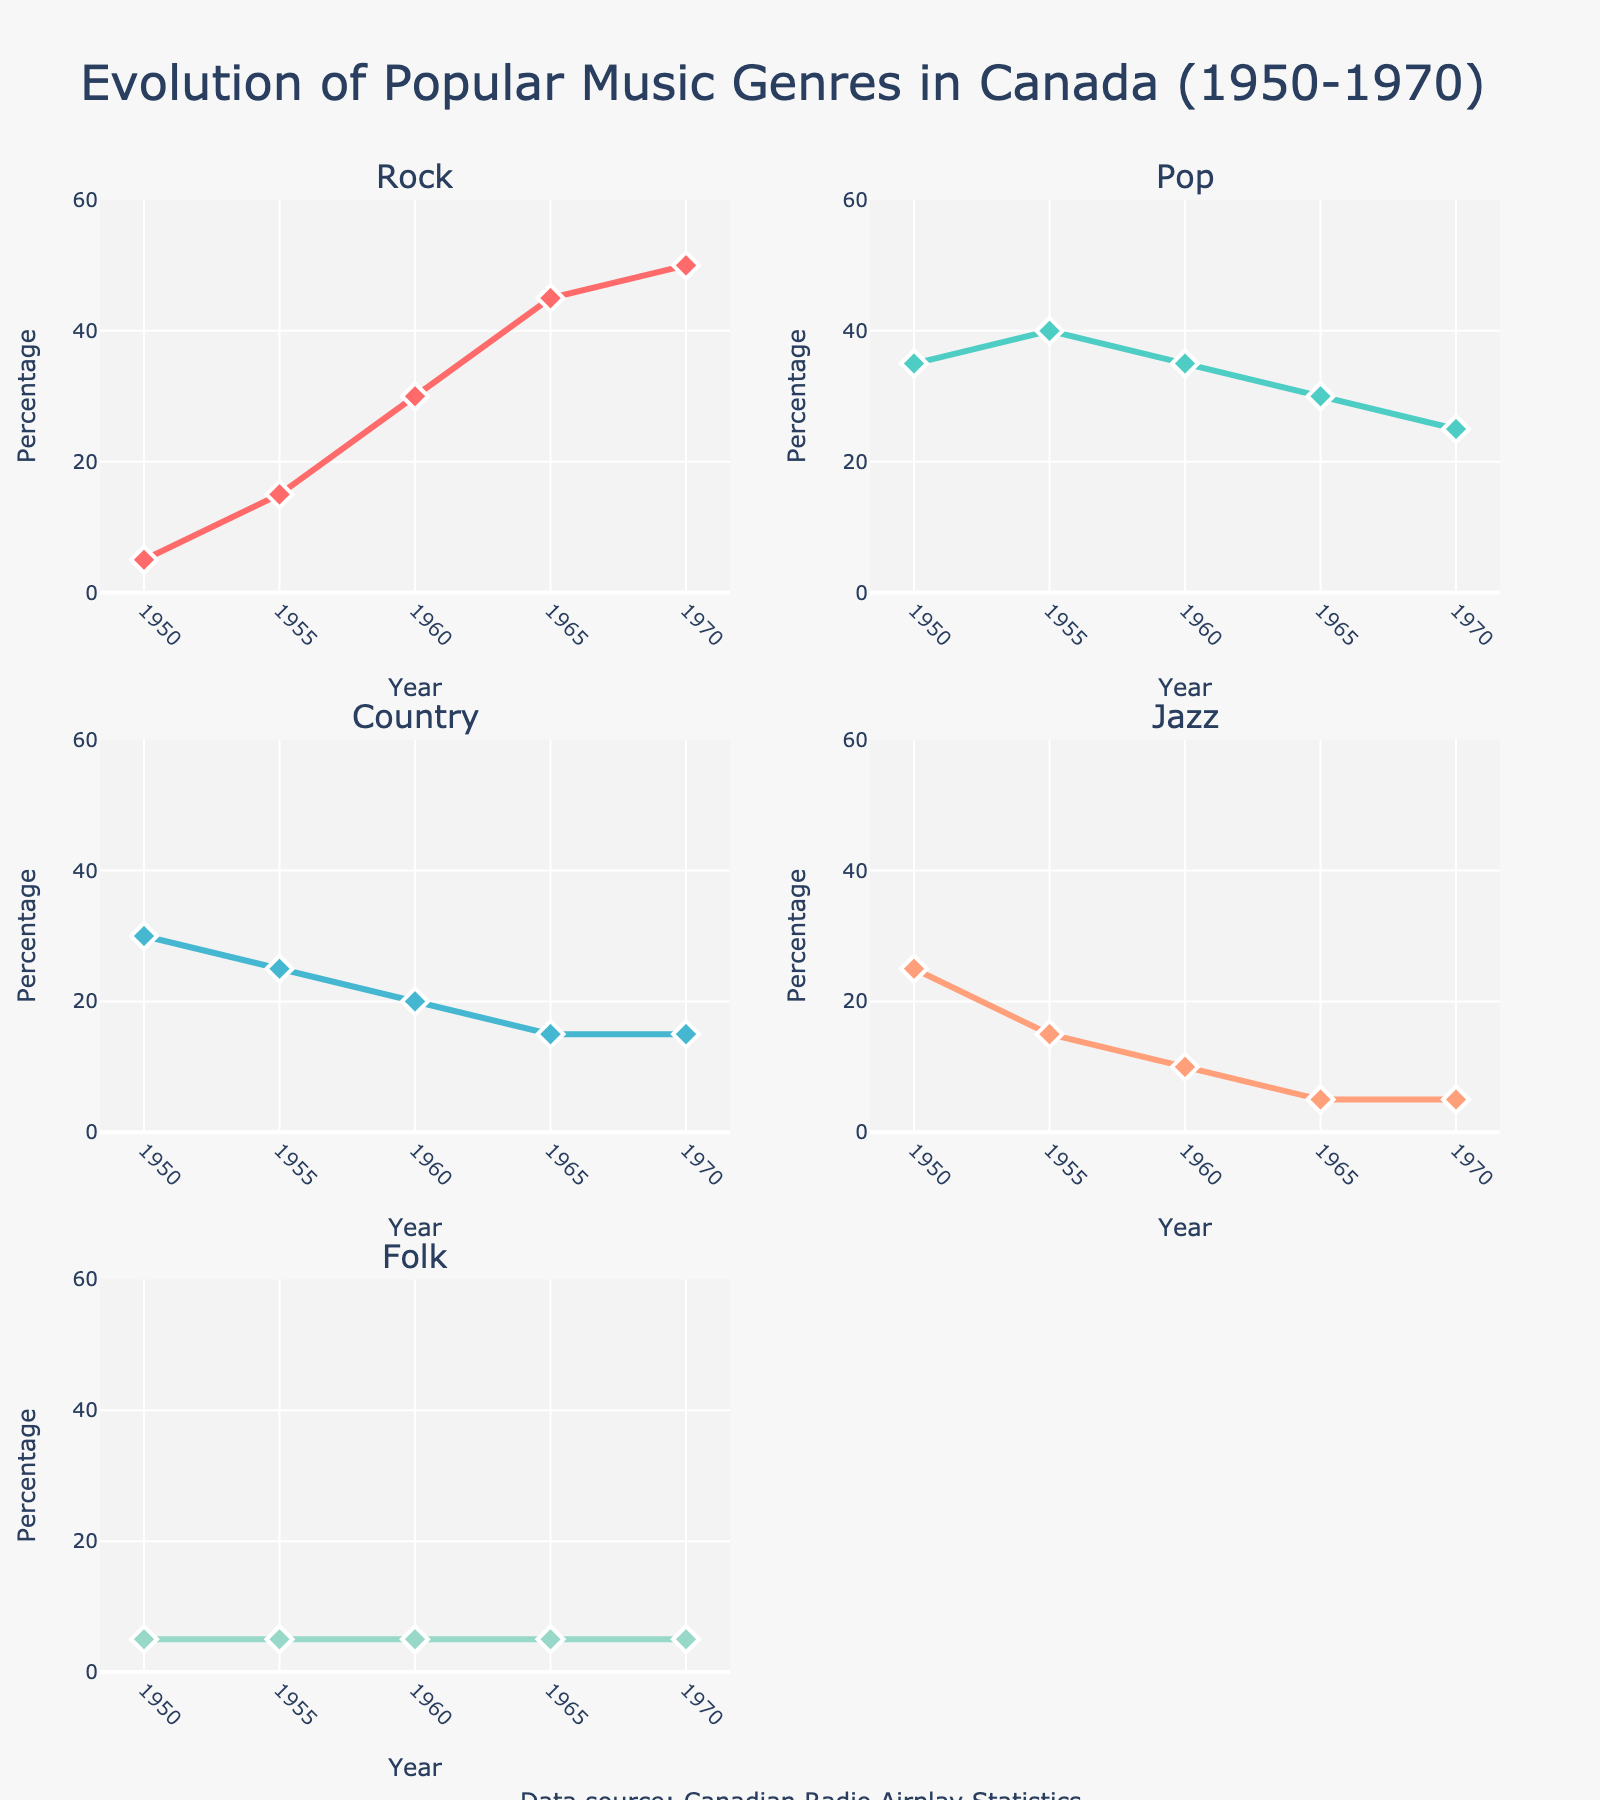What is the title of the figure? The title is found at the top of the figure and provides an overview of the data being shown.
Answer: "Evolution of Popular Music Genres in Canada (1950-1970)" How does the percentage of Rock airplay change from 1950 to 1970? Check the line for Rock in its subplot and compare the percentage in 1950 and 1970. In 1950, it starts at 5%, and in 1970, it reaches 50%.
Answer: It increases by 45% Which year saw the highest percentage of Jazz airplay? Look at the Jazz line and find the highest point on the y-axis between 1950 and 1970. This occurs in 1950 at 25%.
Answer: 1950 Which genre had a constant percentage from 1950 to 1970? Observe each genre's line. The Folk line remains constant at 5% throughout.
Answer: Folk What is the difference in Country airplay percentage between 1960 and 1965? Refer to the subplots for Country in 1960 (20%) and 1965 (15%), then calculate the difference as 20% - 15%.
Answer: 5% From 1950 to 1970, in which genre did the percentage of airplay decrease most? Compare the decrease in percentages for all genres. Pop decreased from 35% to 25% (a drop of 15%), which is the largest.
Answer: Pop Which genre overtook Jazz airplay percentage-wise by 1960? Look at the lines for Jazz and other genres in 1960. Jazz is at 10%, and Rock, at 30%, overtakes it.
Answer: Rock How many subplots are there in the figure? Count the subplots shown in the figure. Each genre has its subplot, and there are five genres.
Answer: 5 What is the total percentage of airplay for all genres combined in 1955? Add the percentages for all genres in 1955: 15% (Rock) + 40% (Pop) + 25% (Country) + 15% (Jazz) + 5% (Folk) = 100%.
Answer: 100% In what year did Pop airplay percentage fall below Rock? Identify where the Pop line crosses below the Rock line. This happens around 1960.
Answer: 1960 